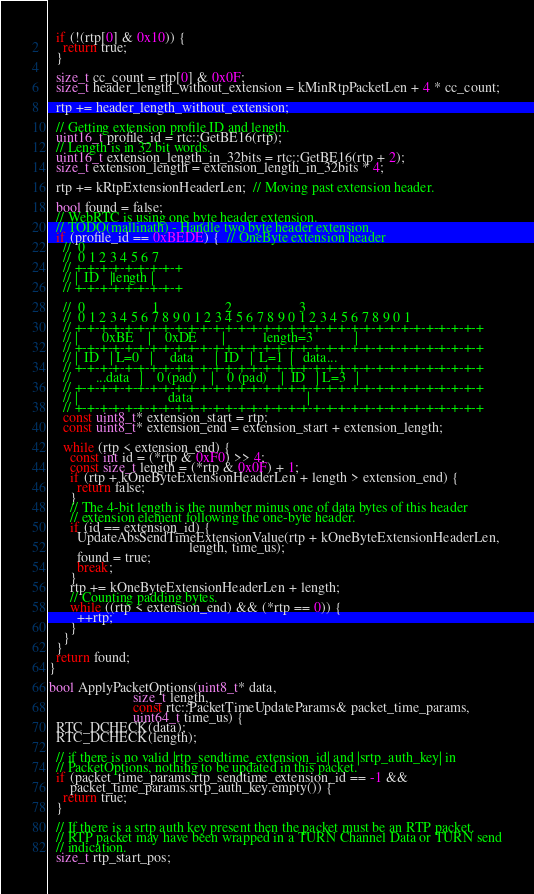<code> <loc_0><loc_0><loc_500><loc_500><_C++_>  if (!(rtp[0] & 0x10)) {
    return true;
  }

  size_t cc_count = rtp[0] & 0x0F;
  size_t header_length_without_extension = kMinRtpPacketLen + 4 * cc_count;

  rtp += header_length_without_extension;

  // Getting extension profile ID and length.
  uint16_t profile_id = rtc::GetBE16(rtp);
  // Length is in 32 bit words.
  uint16_t extension_length_in_32bits = rtc::GetBE16(rtp + 2);
  size_t extension_length = extension_length_in_32bits * 4;

  rtp += kRtpExtensionHeaderLen;  // Moving past extension header.

  bool found = false;
  // WebRTC is using one byte header extension.
  // TODO(mallinath) - Handle two byte header extension.
  if (profile_id == 0xBEDE) {  // OneByte extension header
    //  0
    //  0 1 2 3 4 5 6 7
    // +-+-+-+-+-+-+-+-+
    // |  ID   |length |
    // +-+-+-+-+-+-+-+-+

    //  0                   1                   2                   3
    //  0 1 2 3 4 5 6 7 8 9 0 1 2 3 4 5 6 7 8 9 0 1 2 3 4 5 6 7 8 9 0 1
    // +-+-+-+-+-+-+-+-+-+-+-+-+-+-+-+-+-+-+-+-+-+-+-+-+-+-+-+-+-+-+-+-+
    // |       0xBE    |    0xDE       |           length=3            |
    // +-+-+-+-+-+-+-+-+-+-+-+-+-+-+-+-+-+-+-+-+-+-+-+-+-+-+-+-+-+-+-+-+
    // |  ID   | L=0   |     data      |  ID   |  L=1  |   data...
    // +-+-+-+-+-+-+-+-+-+-+-+-+-+-+-+-+-+-+-+-+-+-+-+-+-+-+-+-+-+-+-+-+
    //       ...data   |    0 (pad)    |    0 (pad)    |  ID   | L=3   |
    // +-+-+-+-+-+-+-+-+-+-+-+-+-+-+-+-+-+-+-+-+-+-+-+-+-+-+-+-+-+-+-+-+
    // |                          data                                 |
    // +-+-+-+-+-+-+-+-+-+-+-+-+-+-+-+-+-+-+-+-+-+-+-+-+-+-+-+-+-+-+-+-+
    const uint8_t* extension_start = rtp;
    const uint8_t* extension_end = extension_start + extension_length;

    while (rtp < extension_end) {
      const int id = (*rtp & 0xF0) >> 4;
      const size_t length = (*rtp & 0x0F) + 1;
      if (rtp + kOneByteExtensionHeaderLen + length > extension_end) {
        return false;
      }
      // The 4-bit length is the number minus one of data bytes of this header
      // extension element following the one-byte header.
      if (id == extension_id) {
        UpdateAbsSendTimeExtensionValue(rtp + kOneByteExtensionHeaderLen,
                                        length, time_us);
        found = true;
        break;
      }
      rtp += kOneByteExtensionHeaderLen + length;
      // Counting padding bytes.
      while ((rtp < extension_end) && (*rtp == 0)) {
        ++rtp;
      }
    }
  }
  return found;
}

bool ApplyPacketOptions(uint8_t* data,
                        size_t length,
                        const rtc::PacketTimeUpdateParams& packet_time_params,
                        uint64_t time_us) {
  RTC_DCHECK(data);
  RTC_DCHECK(length);

  // if there is no valid |rtp_sendtime_extension_id| and |srtp_auth_key| in
  // PacketOptions, nothing to be updated in this packet.
  if (packet_time_params.rtp_sendtime_extension_id == -1 &&
      packet_time_params.srtp_auth_key.empty()) {
    return true;
  }

  // If there is a srtp auth key present then the packet must be an RTP packet.
  // RTP packet may have been wrapped in a TURN Channel Data or TURN send
  // indication.
  size_t rtp_start_pos;</code> 